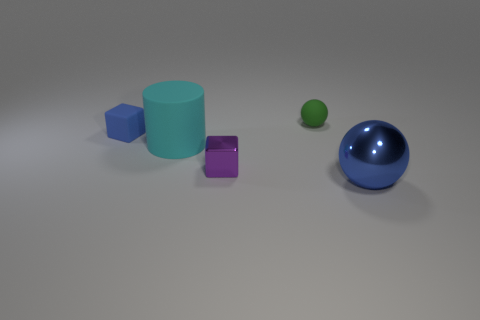What shape is the metal thing that is the same color as the small matte cube?
Keep it short and to the point. Sphere. Is there anything else that is the same shape as the big cyan matte thing?
Keep it short and to the point. No. What is the color of the large object to the left of the small thing right of the small purple metallic cube?
Your response must be concise. Cyan. The tiny blue rubber thing is what shape?
Give a very brief answer. Cube. There is a rubber object that is both on the right side of the matte block and in front of the tiny green thing; what shape is it?
Give a very brief answer. Cylinder. The cube that is made of the same material as the large blue thing is what color?
Offer a terse response. Purple. What is the shape of the cyan object that is behind the big thing that is right of the sphere left of the big blue sphere?
Provide a short and direct response. Cylinder. The blue shiny ball has what size?
Your answer should be compact. Large. There is a green thing that is made of the same material as the big cylinder; what shape is it?
Your answer should be compact. Sphere. Are there fewer blocks that are in front of the large shiny ball than cyan things?
Ensure brevity in your answer.  Yes. 